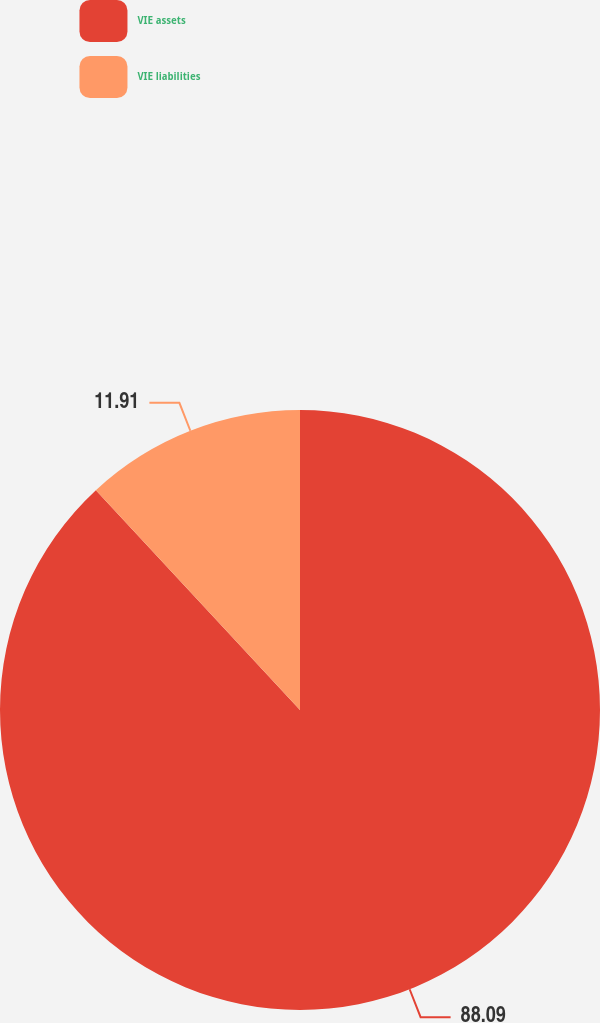Convert chart. <chart><loc_0><loc_0><loc_500><loc_500><pie_chart><fcel>VIE assets<fcel>VIE liabilities<nl><fcel>88.09%<fcel>11.91%<nl></chart> 